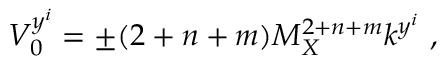<formula> <loc_0><loc_0><loc_500><loc_500>V _ { 0 } ^ { y ^ { i } } = \pm ( 2 + n + m ) M _ { X } ^ { 2 + n + m } k ^ { y ^ { i } } , \,</formula> 